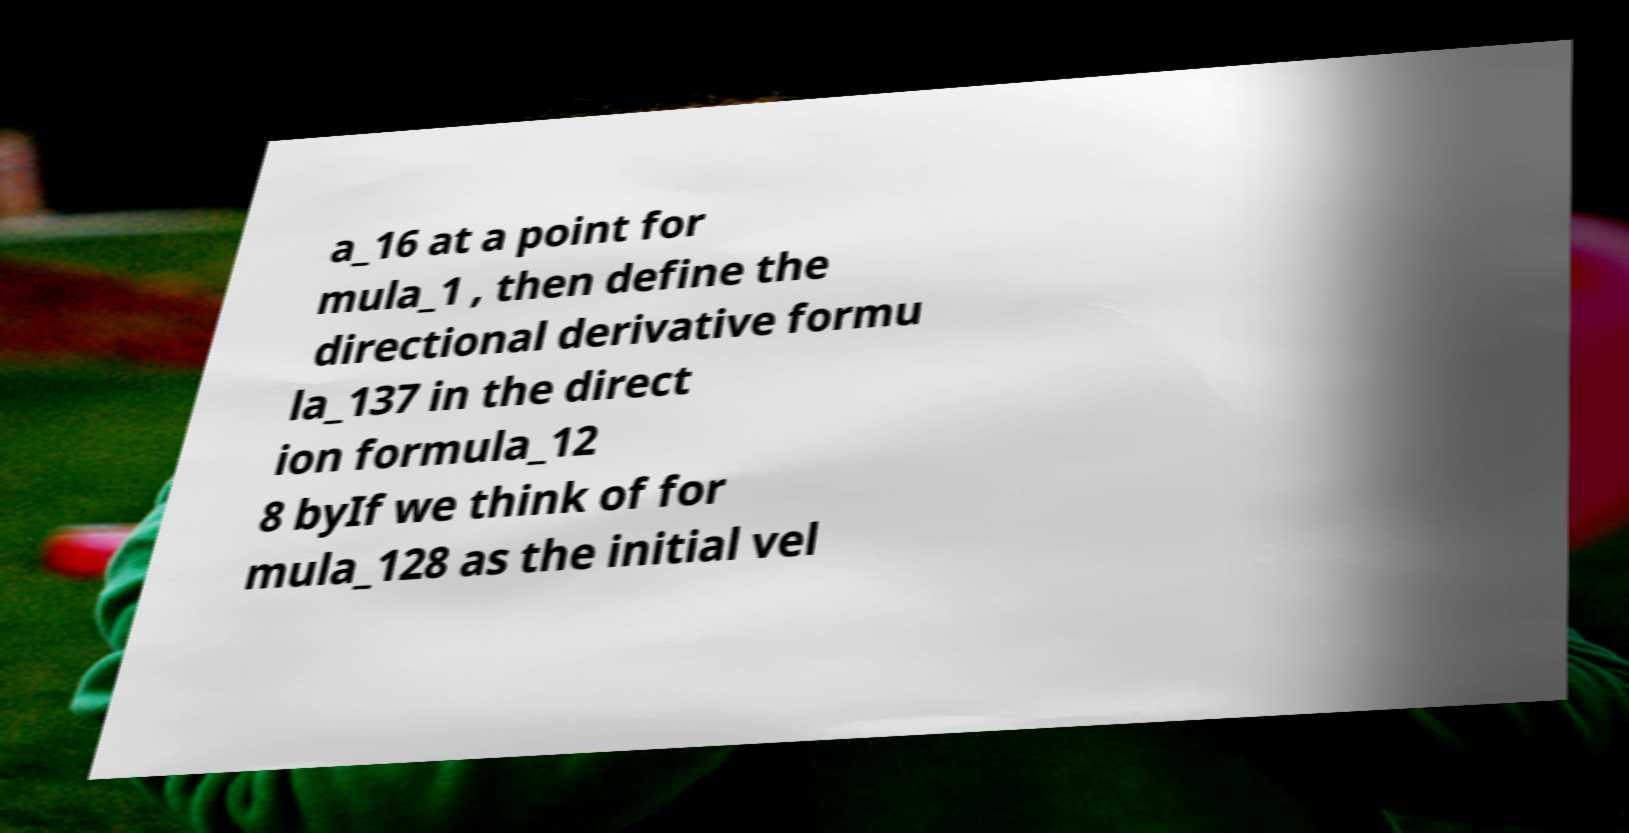Could you assist in decoding the text presented in this image and type it out clearly? a_16 at a point for mula_1 , then define the directional derivative formu la_137 in the direct ion formula_12 8 byIf we think of for mula_128 as the initial vel 